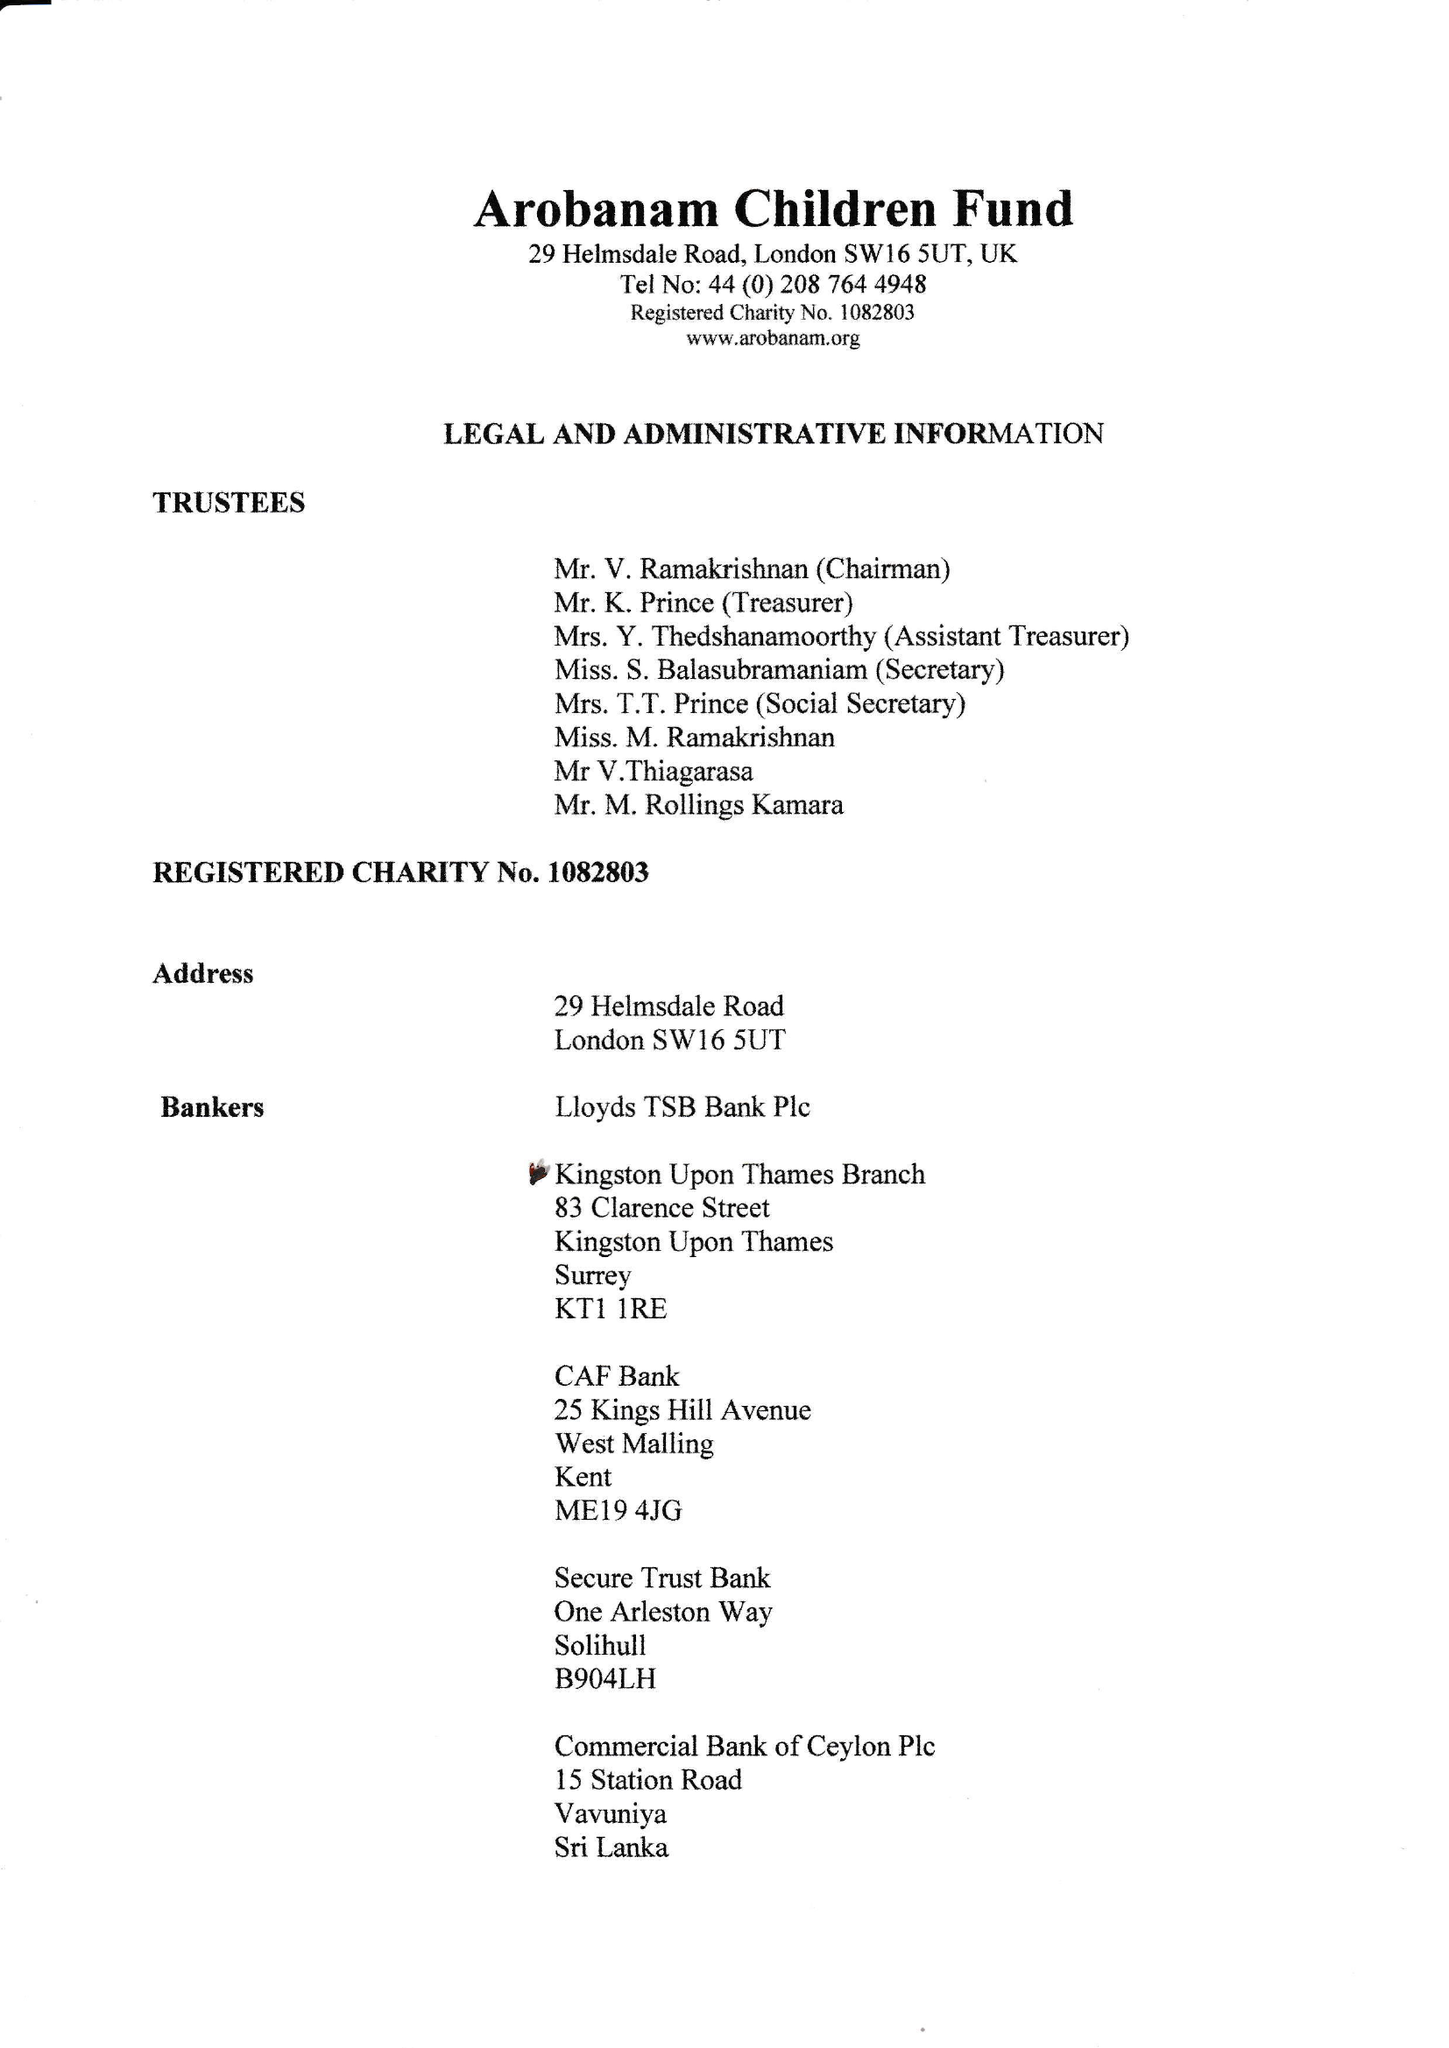What is the value for the address__street_line?
Answer the question using a single word or phrase. 29 HELMSDALE ROAD 